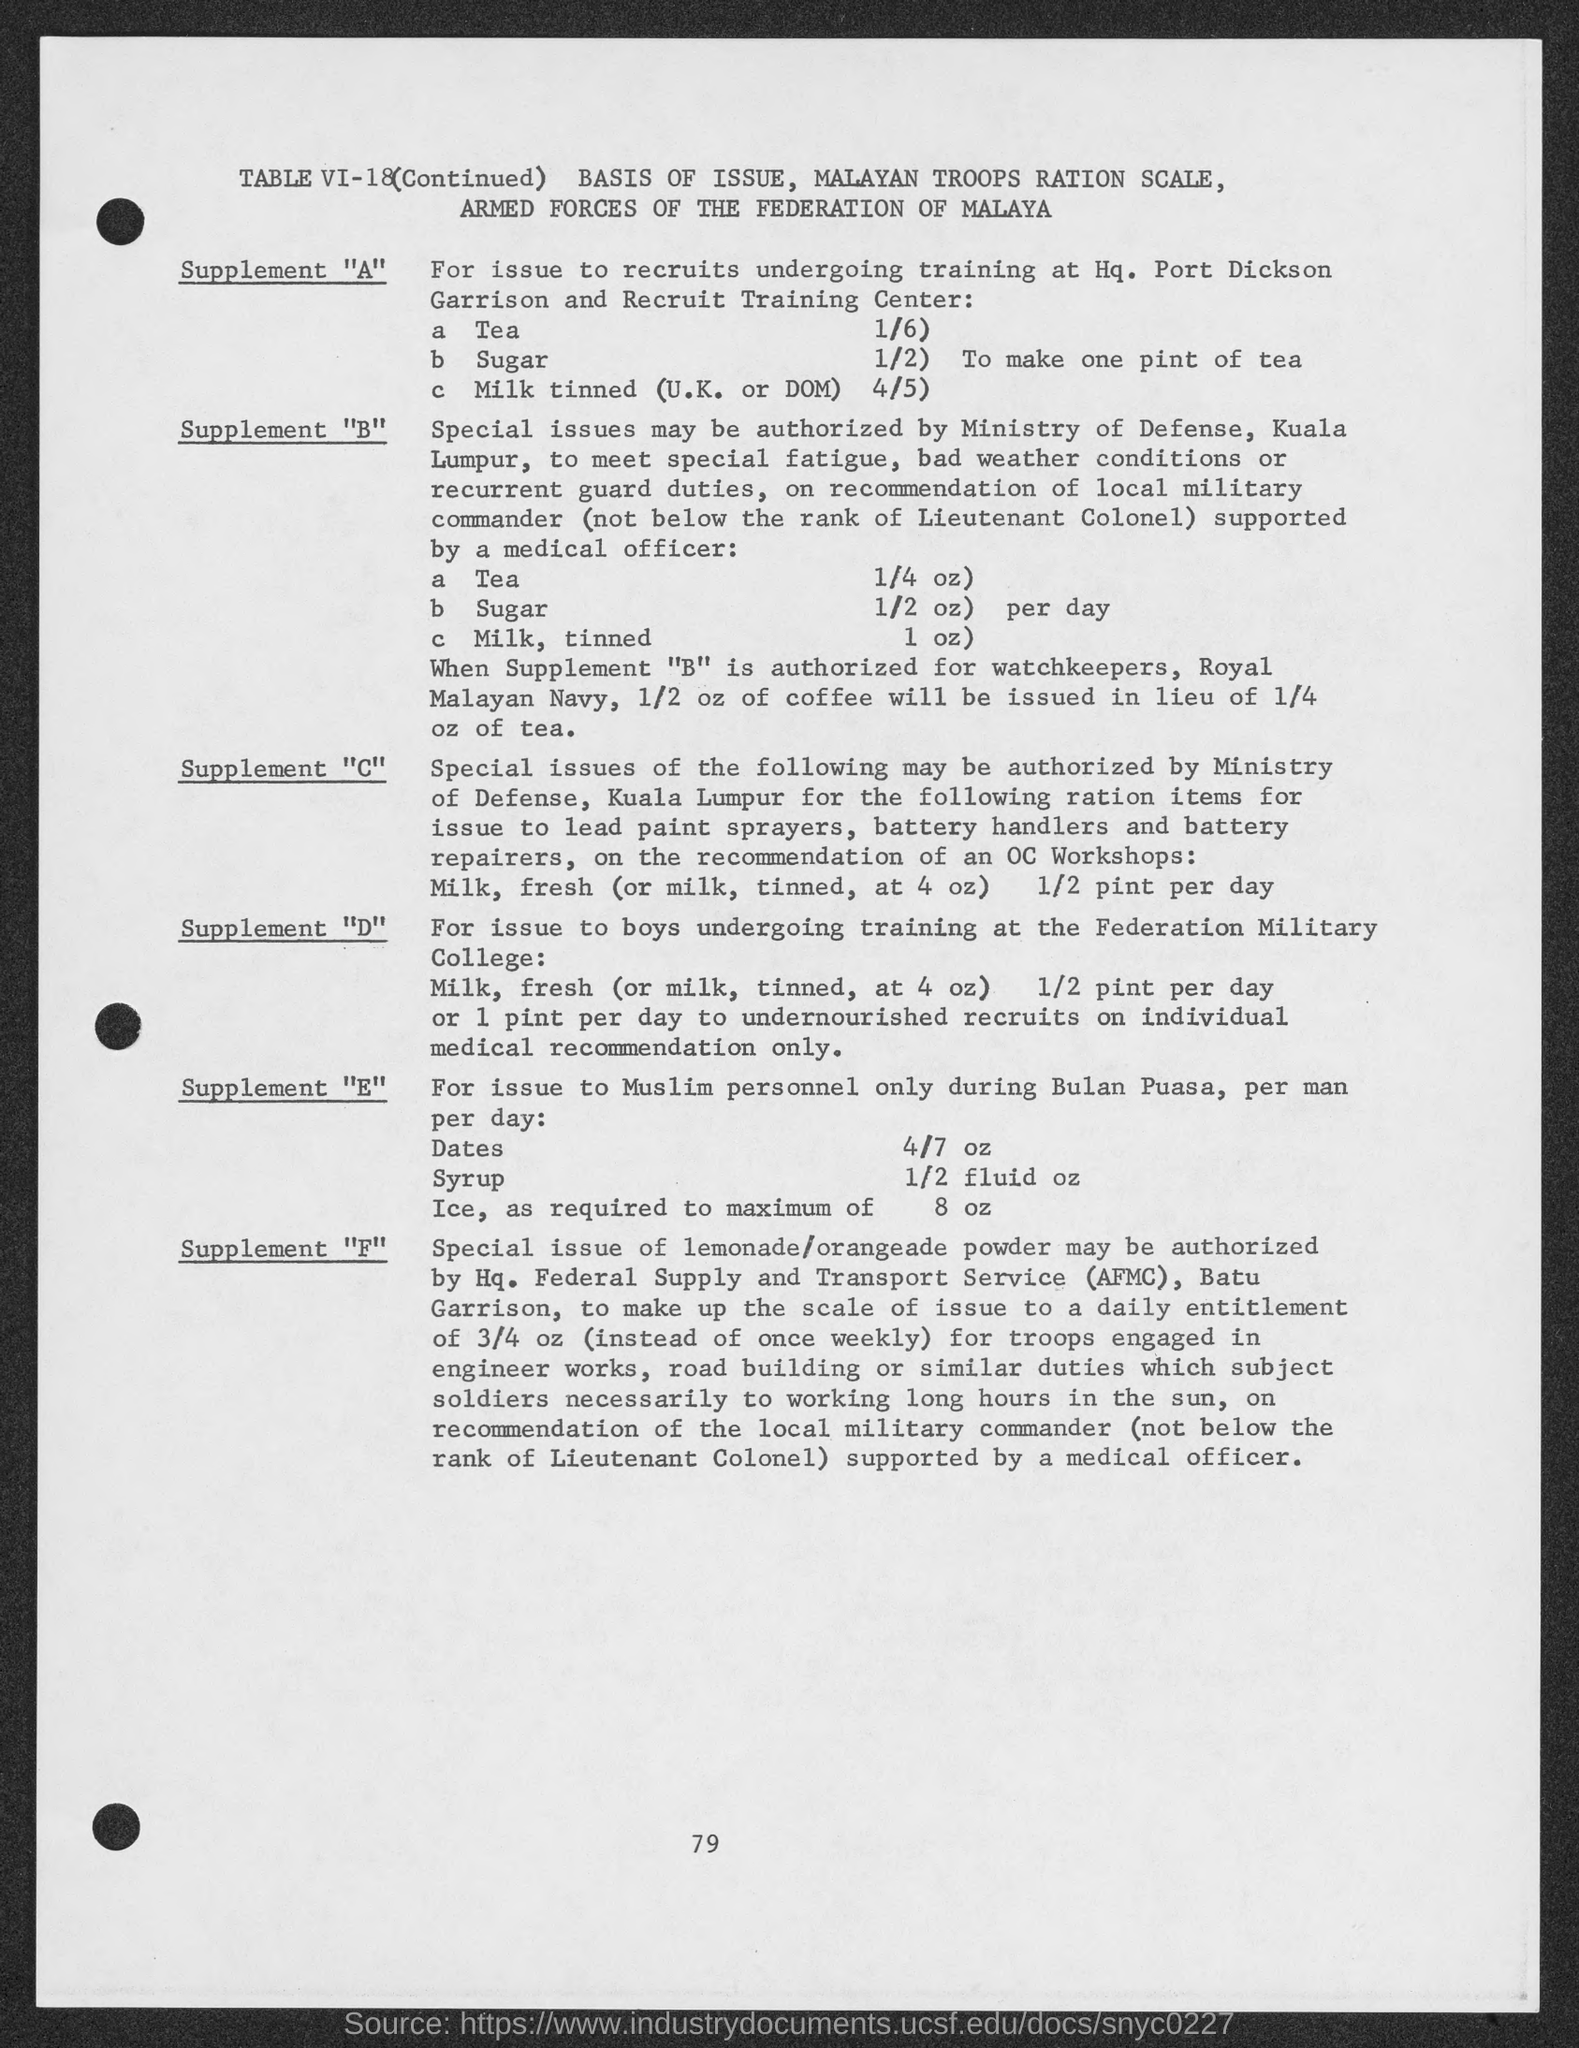What is the page number?
Your response must be concise. 79. What is the table number?
Ensure brevity in your answer.  VI-18. 